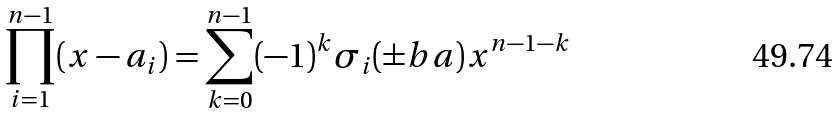Convert formula to latex. <formula><loc_0><loc_0><loc_500><loc_500>\prod _ { i = 1 } ^ { n - 1 } ( x - a _ { i } ) = \sum _ { k = 0 } ^ { n - 1 } ( - 1 ) ^ { k } \sigma _ { i } ( \pm b { a } ) x ^ { n - 1 - k }</formula> 